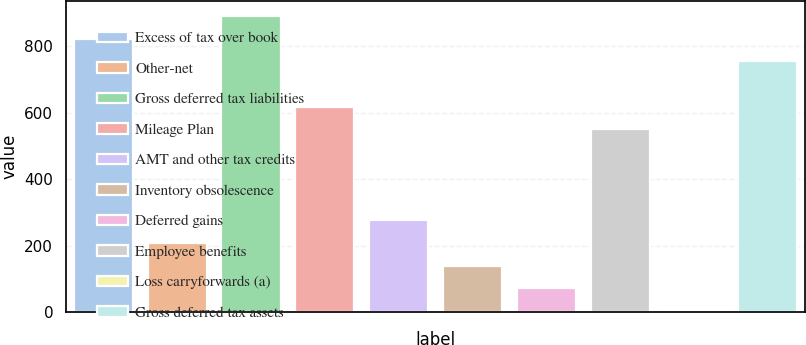<chart> <loc_0><loc_0><loc_500><loc_500><bar_chart><fcel>Excess of tax over book<fcel>Other-net<fcel>Gross deferred tax liabilities<fcel>Mileage Plan<fcel>AMT and other tax credits<fcel>Inventory obsolescence<fcel>Deferred gains<fcel>Employee benefits<fcel>Loss carryforwards (a)<fcel>Gross deferred tax assets<nl><fcel>821.9<fcel>208.55<fcel>890.05<fcel>617.45<fcel>276.7<fcel>140.4<fcel>72.25<fcel>549.3<fcel>4.1<fcel>753.75<nl></chart> 